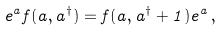<formula> <loc_0><loc_0><loc_500><loc_500>e ^ { a } f ( a , a ^ { \dagger } ) = f ( a , a ^ { \dagger } + 1 ) e ^ { a } \, ,</formula> 